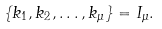<formula> <loc_0><loc_0><loc_500><loc_500>\left \{ k _ { 1 } , k _ { 2 } , \dots , k _ { \mu } \right \} = I _ { \mu } .</formula> 